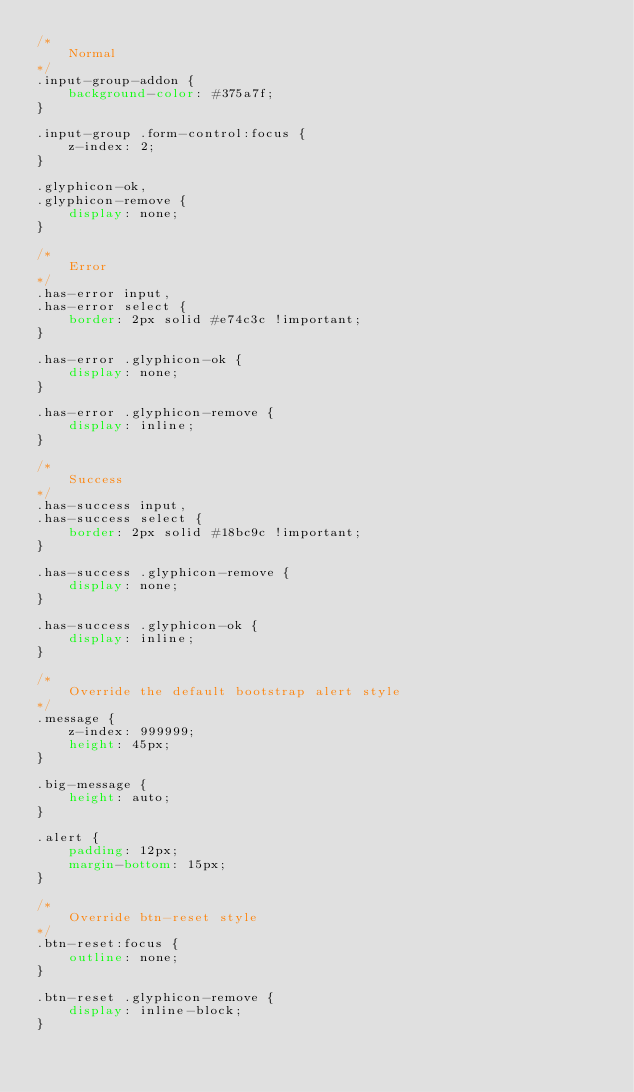<code> <loc_0><loc_0><loc_500><loc_500><_CSS_>/*
    Normal
*/
.input-group-addon {
    background-color: #375a7f;
}

.input-group .form-control:focus {
    z-index: 2;
}

.glyphicon-ok,
.glyphicon-remove {
    display: none;
}

/* 
    Error
*/
.has-error input,
.has-error select {
    border: 2px solid #e74c3c !important;
}

.has-error .glyphicon-ok {
    display: none;
}

.has-error .glyphicon-remove {
    display: inline;
}

/* 
    Success
*/
.has-success input,
.has-success select {
    border: 2px solid #18bc9c !important;
}

.has-success .glyphicon-remove {
    display: none;
}

.has-success .glyphicon-ok {
    display: inline;
}

/* 
    Override the default bootstrap alert style
*/
.message {
    z-index: 999999;
    height: 45px;
}

.big-message {
    height: auto;
}

.alert {
    padding: 12px;
    margin-bottom: 15px;
}

/* 
    Override btn-reset style
*/
.btn-reset:focus {
    outline: none;
}

.btn-reset .glyphicon-remove {
    display: inline-block;
}</code> 